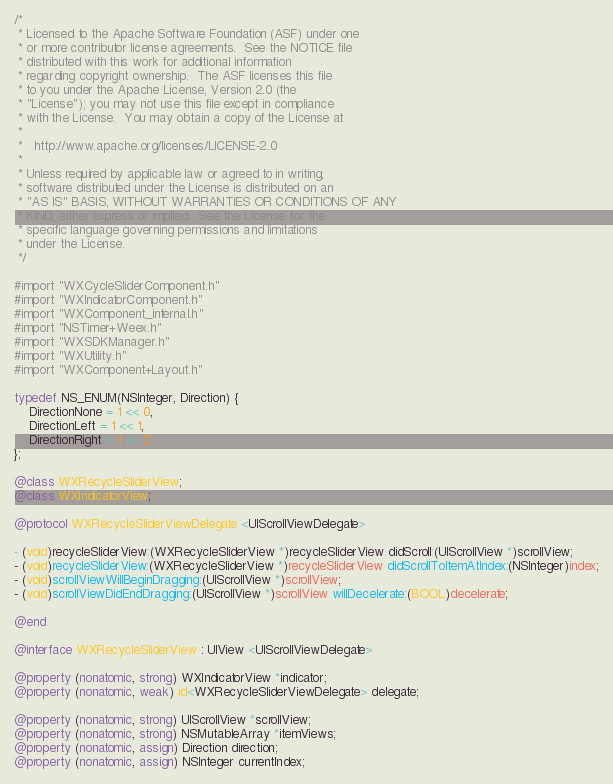<code> <loc_0><loc_0><loc_500><loc_500><_ObjectiveC_>/*
 * Licensed to the Apache Software Foundation (ASF) under one
 * or more contributor license agreements.  See the NOTICE file
 * distributed with this work for additional information
 * regarding copyright ownership.  The ASF licenses this file
 * to you under the Apache License, Version 2.0 (the
 * "License"); you may not use this file except in compliance
 * with the License.  You may obtain a copy of the License at
 *
 *   http://www.apache.org/licenses/LICENSE-2.0
 *
 * Unless required by applicable law or agreed to in writing,
 * software distributed under the License is distributed on an
 * "AS IS" BASIS, WITHOUT WARRANTIES OR CONDITIONS OF ANY
 * KIND, either express or implied.  See the License for the
 * specific language governing permissions and limitations
 * under the License.
 */

#import "WXCycleSliderComponent.h"
#import "WXIndicatorComponent.h"
#import "WXComponent_internal.h"
#import "NSTimer+Weex.h"
#import "WXSDKManager.h"
#import "WXUtility.h"
#import "WXComponent+Layout.h"

typedef NS_ENUM(NSInteger, Direction) {
    DirectionNone = 1 << 0,
    DirectionLeft = 1 << 1,
    DirectionRight = 1 << 2
};

@class WXRecycleSliderView;
@class WXIndicatorView;

@protocol WXRecycleSliderViewDelegate <UIScrollViewDelegate>

- (void)recycleSliderView:(WXRecycleSliderView *)recycleSliderView didScroll:(UIScrollView *)scrollView;
- (void)recycleSliderView:(WXRecycleSliderView *)recycleSliderView didScrollToItemAtIndex:(NSInteger)index;
- (void)scrollViewWillBeginDragging:(UIScrollView *)scrollView;
- (void)scrollViewDidEndDragging:(UIScrollView *)scrollView willDecelerate:(BOOL)decelerate;

@end

@interface WXRecycleSliderView : UIView <UIScrollViewDelegate>

@property (nonatomic, strong) WXIndicatorView *indicator;
@property (nonatomic, weak) id<WXRecycleSliderViewDelegate> delegate;

@property (nonatomic, strong) UIScrollView *scrollView;
@property (nonatomic, strong) NSMutableArray *itemViews;
@property (nonatomic, assign) Direction direction;
@property (nonatomic, assign) NSInteger currentIndex;</code> 